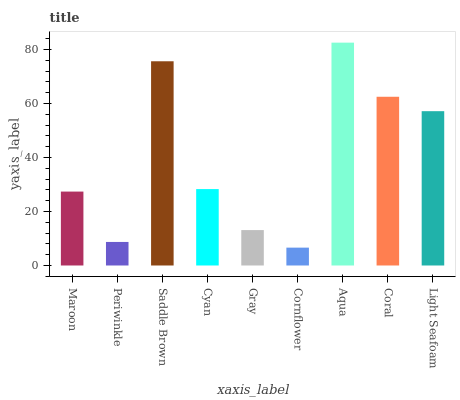Is Cornflower the minimum?
Answer yes or no. Yes. Is Aqua the maximum?
Answer yes or no. Yes. Is Periwinkle the minimum?
Answer yes or no. No. Is Periwinkle the maximum?
Answer yes or no. No. Is Maroon greater than Periwinkle?
Answer yes or no. Yes. Is Periwinkle less than Maroon?
Answer yes or no. Yes. Is Periwinkle greater than Maroon?
Answer yes or no. No. Is Maroon less than Periwinkle?
Answer yes or no. No. Is Cyan the high median?
Answer yes or no. Yes. Is Cyan the low median?
Answer yes or no. Yes. Is Cornflower the high median?
Answer yes or no. No. Is Gray the low median?
Answer yes or no. No. 